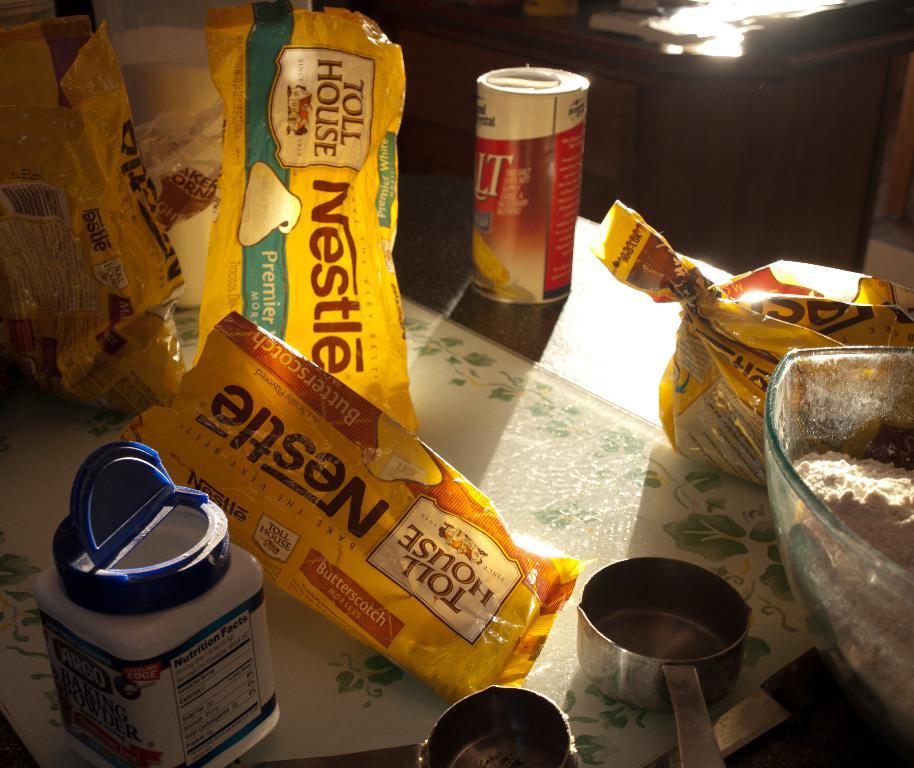What type of chocolate is seen?
Offer a very short reply. Nestle. What brand of chips are these?
Your response must be concise. Nestle. 